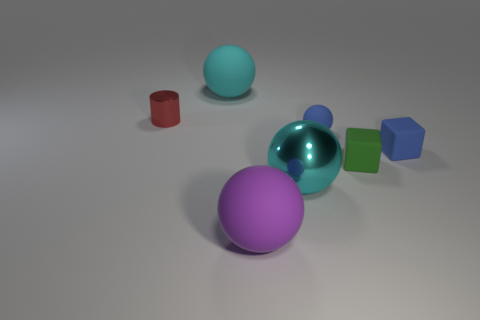Add 3 big rubber spheres. How many objects exist? 10 Subtract all balls. How many objects are left? 3 Add 1 large metal spheres. How many large metal spheres exist? 2 Subtract 0 brown cylinders. How many objects are left? 7 Subtract all blue things. Subtract all tiny red metal cylinders. How many objects are left? 4 Add 6 small matte objects. How many small matte objects are left? 9 